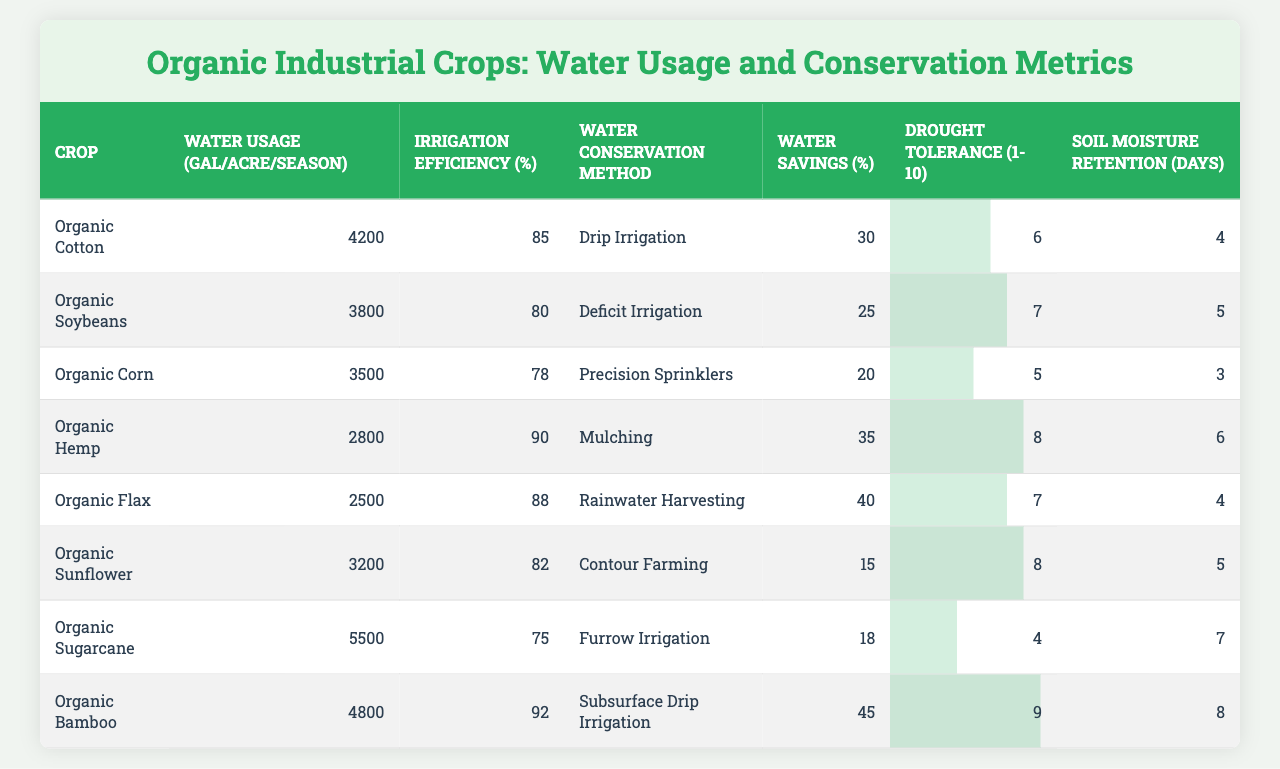What is the water usage for Organic Corn? Referencing the table, the water usage for Organic Corn is listed as 3500 gallons per acre per season.
Answer: 3500 Which crop has the highest irrigation efficiency? The irrigation efficiency column indicates Organic Bamboo has the highest efficiency at 92%.
Answer: 92% What water conservation method is used for Organic Cotton? Looking at the table, the water conservation method used for Organic Cotton is Drip Irrigation.
Answer: Drip Irrigation Which crop has the lowest water savings percentage? Comparing the water savings percentages, Organic Corn has the lowest at 20%.
Answer: 20% If Organic Hemp's water savings is 35%, how does it compare with Organic Sunflower's water savings? Organic Hemp's water savings of 35% is higher than Organic Sunflower's at 15%, indicating that Organic Hemp saves more water.
Answer: Organic Hemp saves more water What is the average soil moisture retention for all crops? To find the average, sum all soil moisture retention values (4 + 5 + 3 + 6 + 4 + 5 + 7 + 8 = 42) and divide by the number of crops (8), which results in 42 / 8 = 5.25 days.
Answer: 5.25 days Is the drought tolerance of Organic Sugarcane higher than that of Organic Flax? Organic Sugarcane has a drought tolerance of 4 and Organic Flax has a tolerance of 7. Therefore, Organic Flax has a higher drought tolerance than Organic Sugarcane.
Answer: No Which crop is most effective in terms of water savings and drought tolerance combined? Organic Bamboo has the highest water savings at 45% and the highest drought tolerance at 9, making it the most effective when combining both metrics.
Answer: Organic Bamboo How much more water does Organic Cotton use compared to Organic Flax? The water usage for Organic Cotton is 4200 gallons and for Organic Flax is 2500 gallons. Therefore, Organic Cotton uses 4200 - 2500 = 1700 gallons more water compared to Organic Flax.
Answer: 1700 gallons Which crops have an irrigation efficiency greater than 85%? The crops with irrigation efficiency greater than 85% are Organic Cotton (85%), Organic Hemp (90%), and Organic Bamboo (92%).
Answer: Organic Hemp and Organic Bamboo 